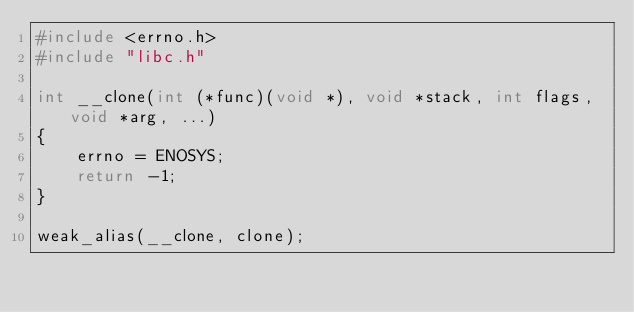<code> <loc_0><loc_0><loc_500><loc_500><_C_>#include <errno.h>
#include "libc.h"

int __clone(int (*func)(void *), void *stack, int flags, void *arg, ...)
{
	errno = ENOSYS;
	return -1;
}

weak_alias(__clone, clone);
</code> 